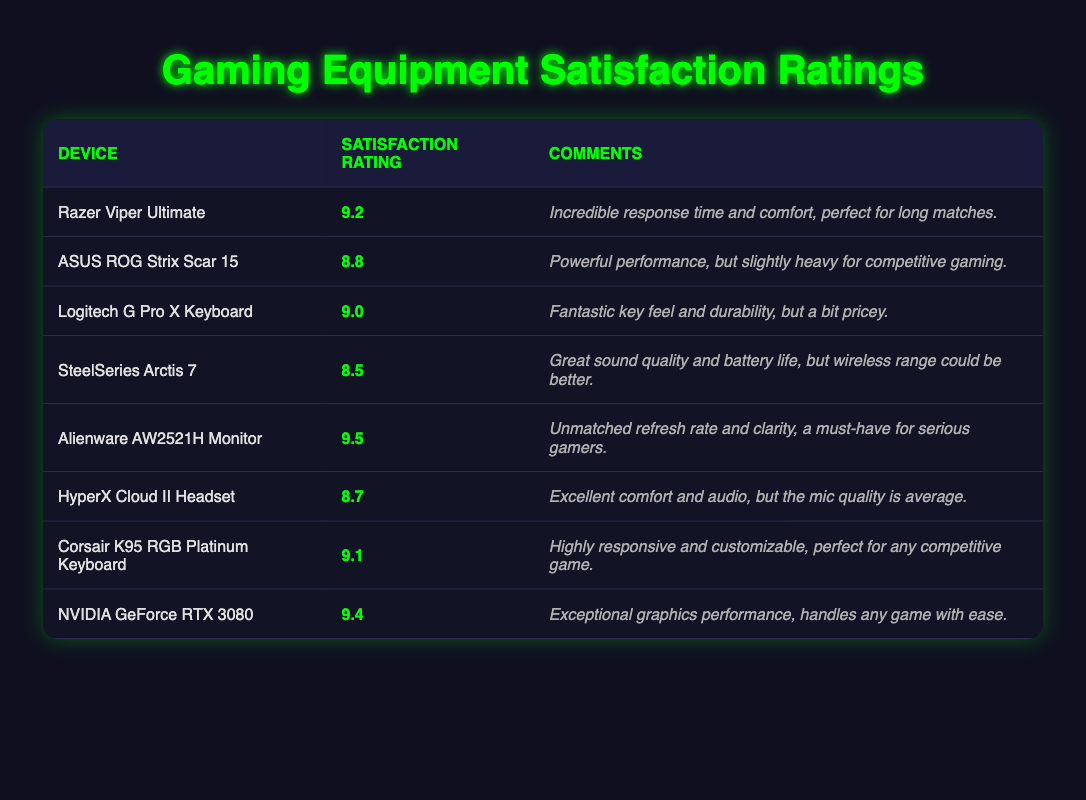What is the satisfaction rating for the Alienware AW2521H Monitor? The Alienware AW2521H Monitor is listed in the table, and its associated satisfaction rating is found in the second column. It shows a rating of 9.5.
Answer: 9.5 What device has the highest user satisfaction rating? By inspecting the satisfaction ratings in the second column, the highest rating is 9.5 for the Alienware AW2521H Monitor.
Answer: Alienware AW2521H Monitor Which device has a satisfaction rating just below 9.0? Looking at the table, the device right below 9.0 is the SteelSeries Arctis 7 with a rating of 8.5.
Answer: SteelSeries Arctis 7 What is the average satisfaction rating of the devices listed? To calculate the average, sum all the ratings (9.2 + 8.8 + 9.0 + 8.5 + 9.5 + 8.7 + 9.1 + 9.4 = 72.2) and divide by the number of devices (8). Therefore, the average is 72.2 / 8 = 9.025.
Answer: 9.025 Is the HyperX Cloud II Headset rated above 9.0? Checking the satisfaction rating for the HyperX Cloud II Headset, it shows a rating of 8.7, which is below 9.0.
Answer: No How many devices have a satisfaction rating of 9.0 or higher? Counting the devices with ratings 9.0 and above: Razer Viper Ultimate (9.2), Logitech G Pro X Keyboard (9.0), Corsair K95 RGB Platinum Keyboard (9.1), NVIDIA GeForce RTX 3080 (9.4), and Alienware AW2521H Monitor (9.5), gives us a total of 5 devices.
Answer: 5 What is the difference in satisfaction ratings between the NVIDIA GeForce RTX 3080 and the SteelSeries Arctis 7? The NVIDIA GeForce RTX 3080 has a rating of 9.4, and the SteelSeries Arctis 7 has a rating of 8.5. Subtracting these gives 9.4 - 8.5 = 0.9.
Answer: 0.9 Has any device received a comment about being heavy for competitive gaming? The ASUS ROG Strix Scar 15 is the only device whose comment mentions it being "slightly heavy for competitive gaming." Thus, the answer is yes.
Answer: Yes 